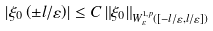Convert formula to latex. <formula><loc_0><loc_0><loc_500><loc_500>\left | \xi _ { 0 } \left ( \pm l / \varepsilon \right ) \right | \leq C \left \| \xi _ { 0 } \right \| _ { W _ { \varepsilon } ^ { 1 , p } \left ( [ - l / \varepsilon , l / \varepsilon ] \right ) }</formula> 